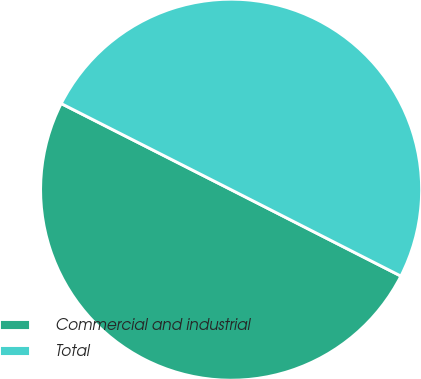Convert chart to OTSL. <chart><loc_0><loc_0><loc_500><loc_500><pie_chart><fcel>Commercial and industrial<fcel>Total<nl><fcel>49.98%<fcel>50.02%<nl></chart> 